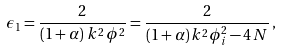Convert formula to latex. <formula><loc_0><loc_0><loc_500><loc_500>\epsilon _ { 1 } = \frac { 2 } { \left ( 1 + \alpha \right ) \, k ^ { 2 } \, \phi ^ { 2 } } = \frac { 2 } { ( 1 + \alpha ) \, k ^ { 2 } \phi _ { i } ^ { 2 } - 4 \, N } \, ,</formula> 